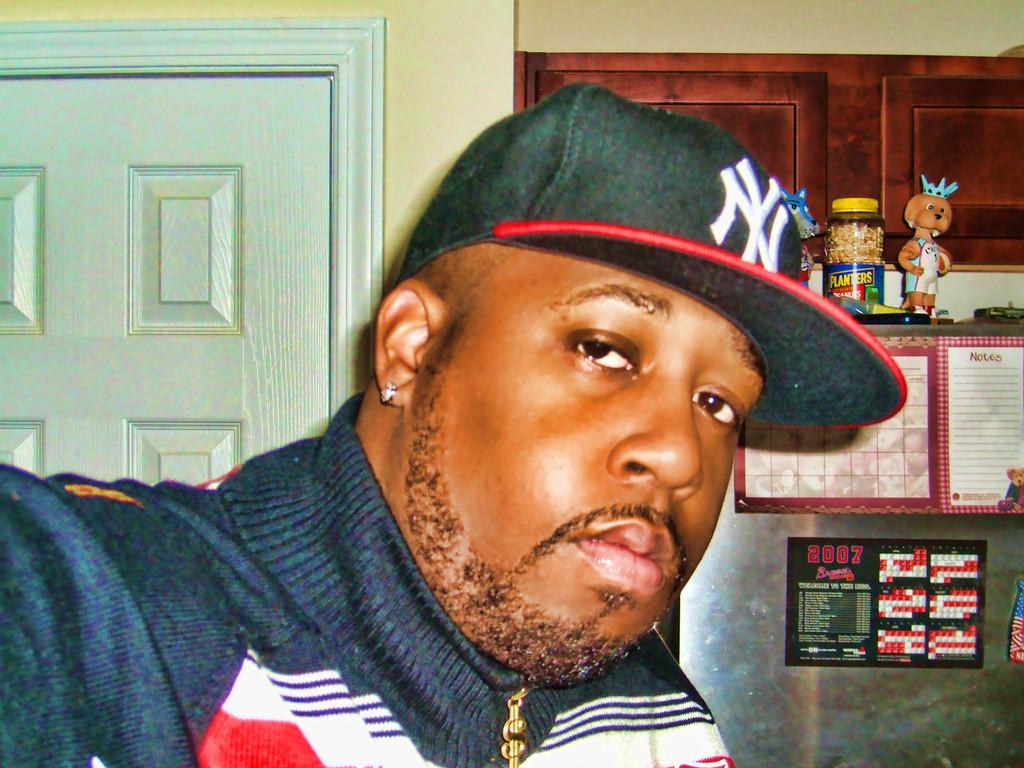Who is present in the image? There is a man in the image. What is the man wearing on his head? The man is wearing a cap. What can be seen in the background of the image? There is a door visible in the image. What object can be seen on a surface in the image? There is a jar in the image. What type of items can be seen in the image? There are toys in the image. What type of furniture is present in the image? There are cupboards in the image. What is on the wall in the image? There are posters on the wall in the image. What type of zephyr can be seen blowing through the image? There is no zephyr present in the image; it is a still image. 